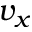<formula> <loc_0><loc_0><loc_500><loc_500>v _ { x }</formula> 